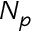Convert formula to latex. <formula><loc_0><loc_0><loc_500><loc_500>N _ { p }</formula> 